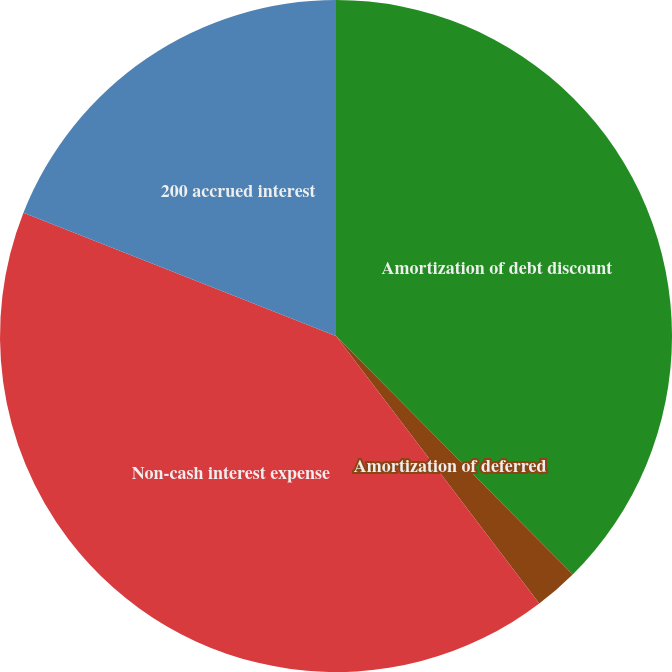<chart> <loc_0><loc_0><loc_500><loc_500><pie_chart><fcel>Amortization of debt discount<fcel>Amortization of deferred<fcel>Non-cash interest expense<fcel>200 accrued interest<nl><fcel>37.56%<fcel>2.1%<fcel>41.32%<fcel>19.02%<nl></chart> 